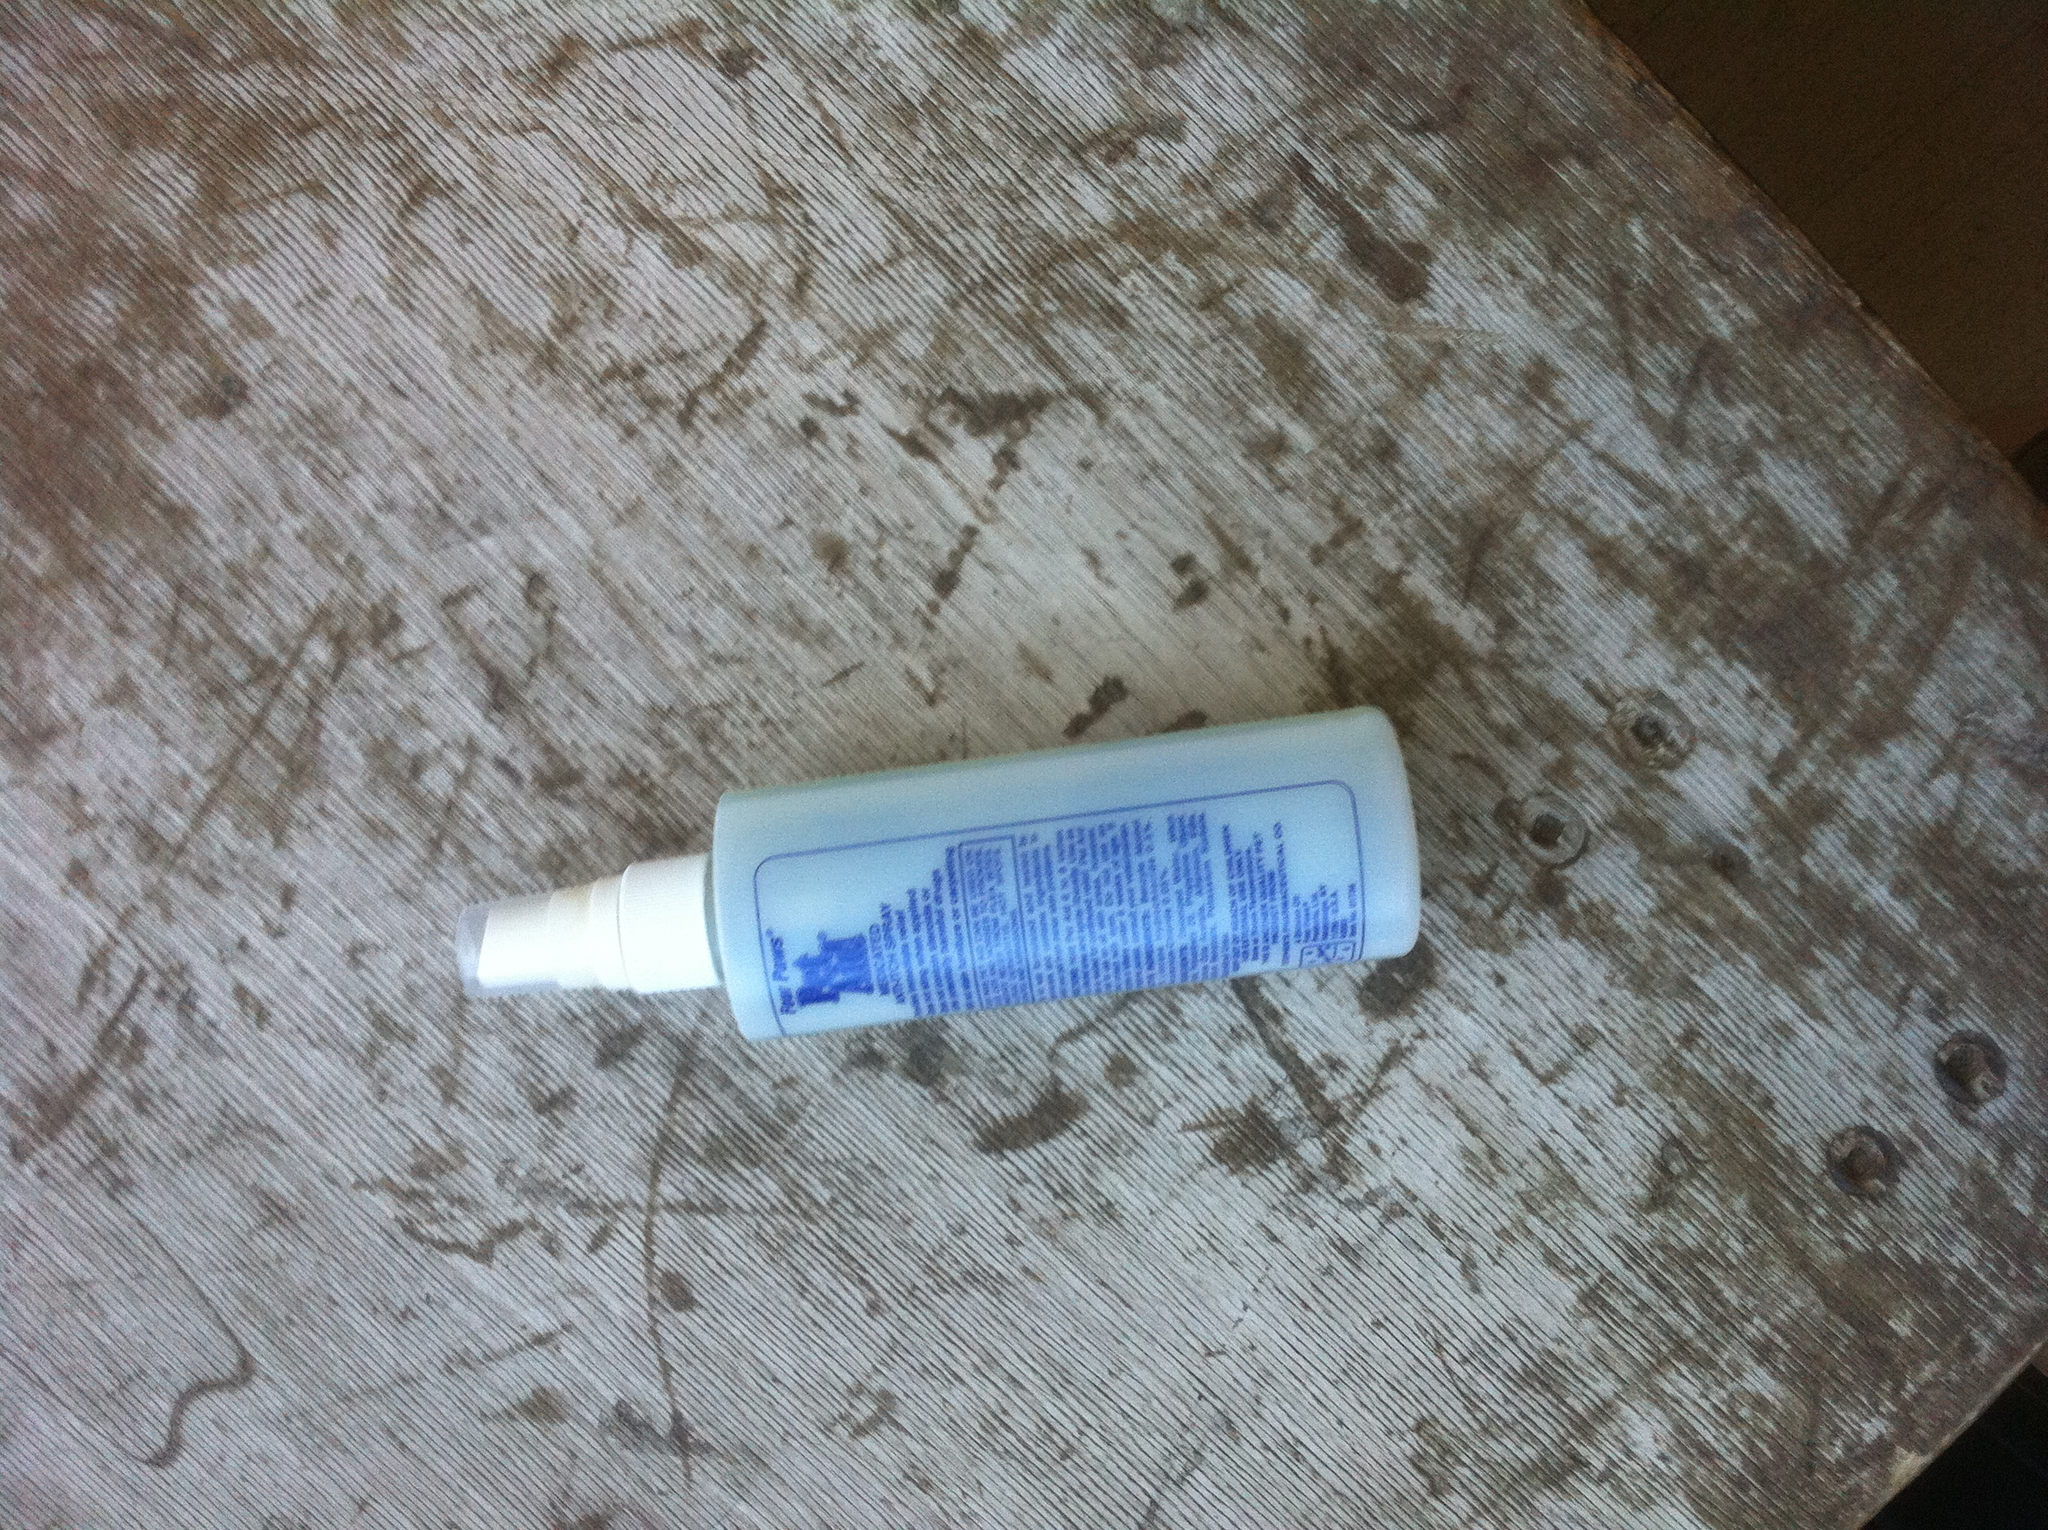Which product is this? The image shows a spray bottle, likely containing a skin care or cosmetic product based on the appearance and information on the label. 